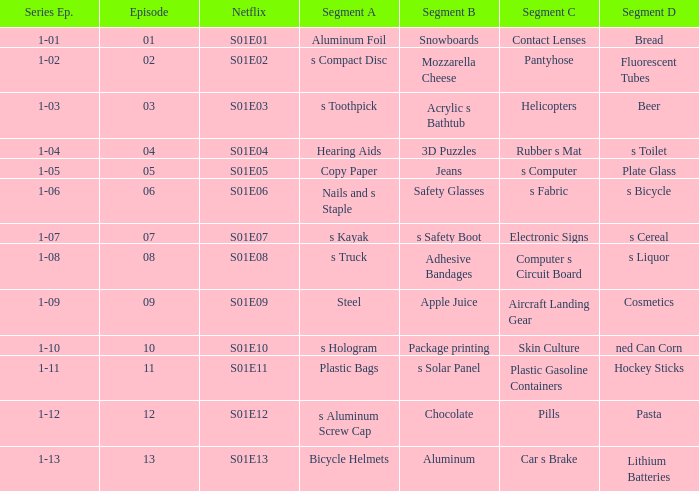What is the series episode number with a segment of D, and having fluorescent tubes? 1-02. 